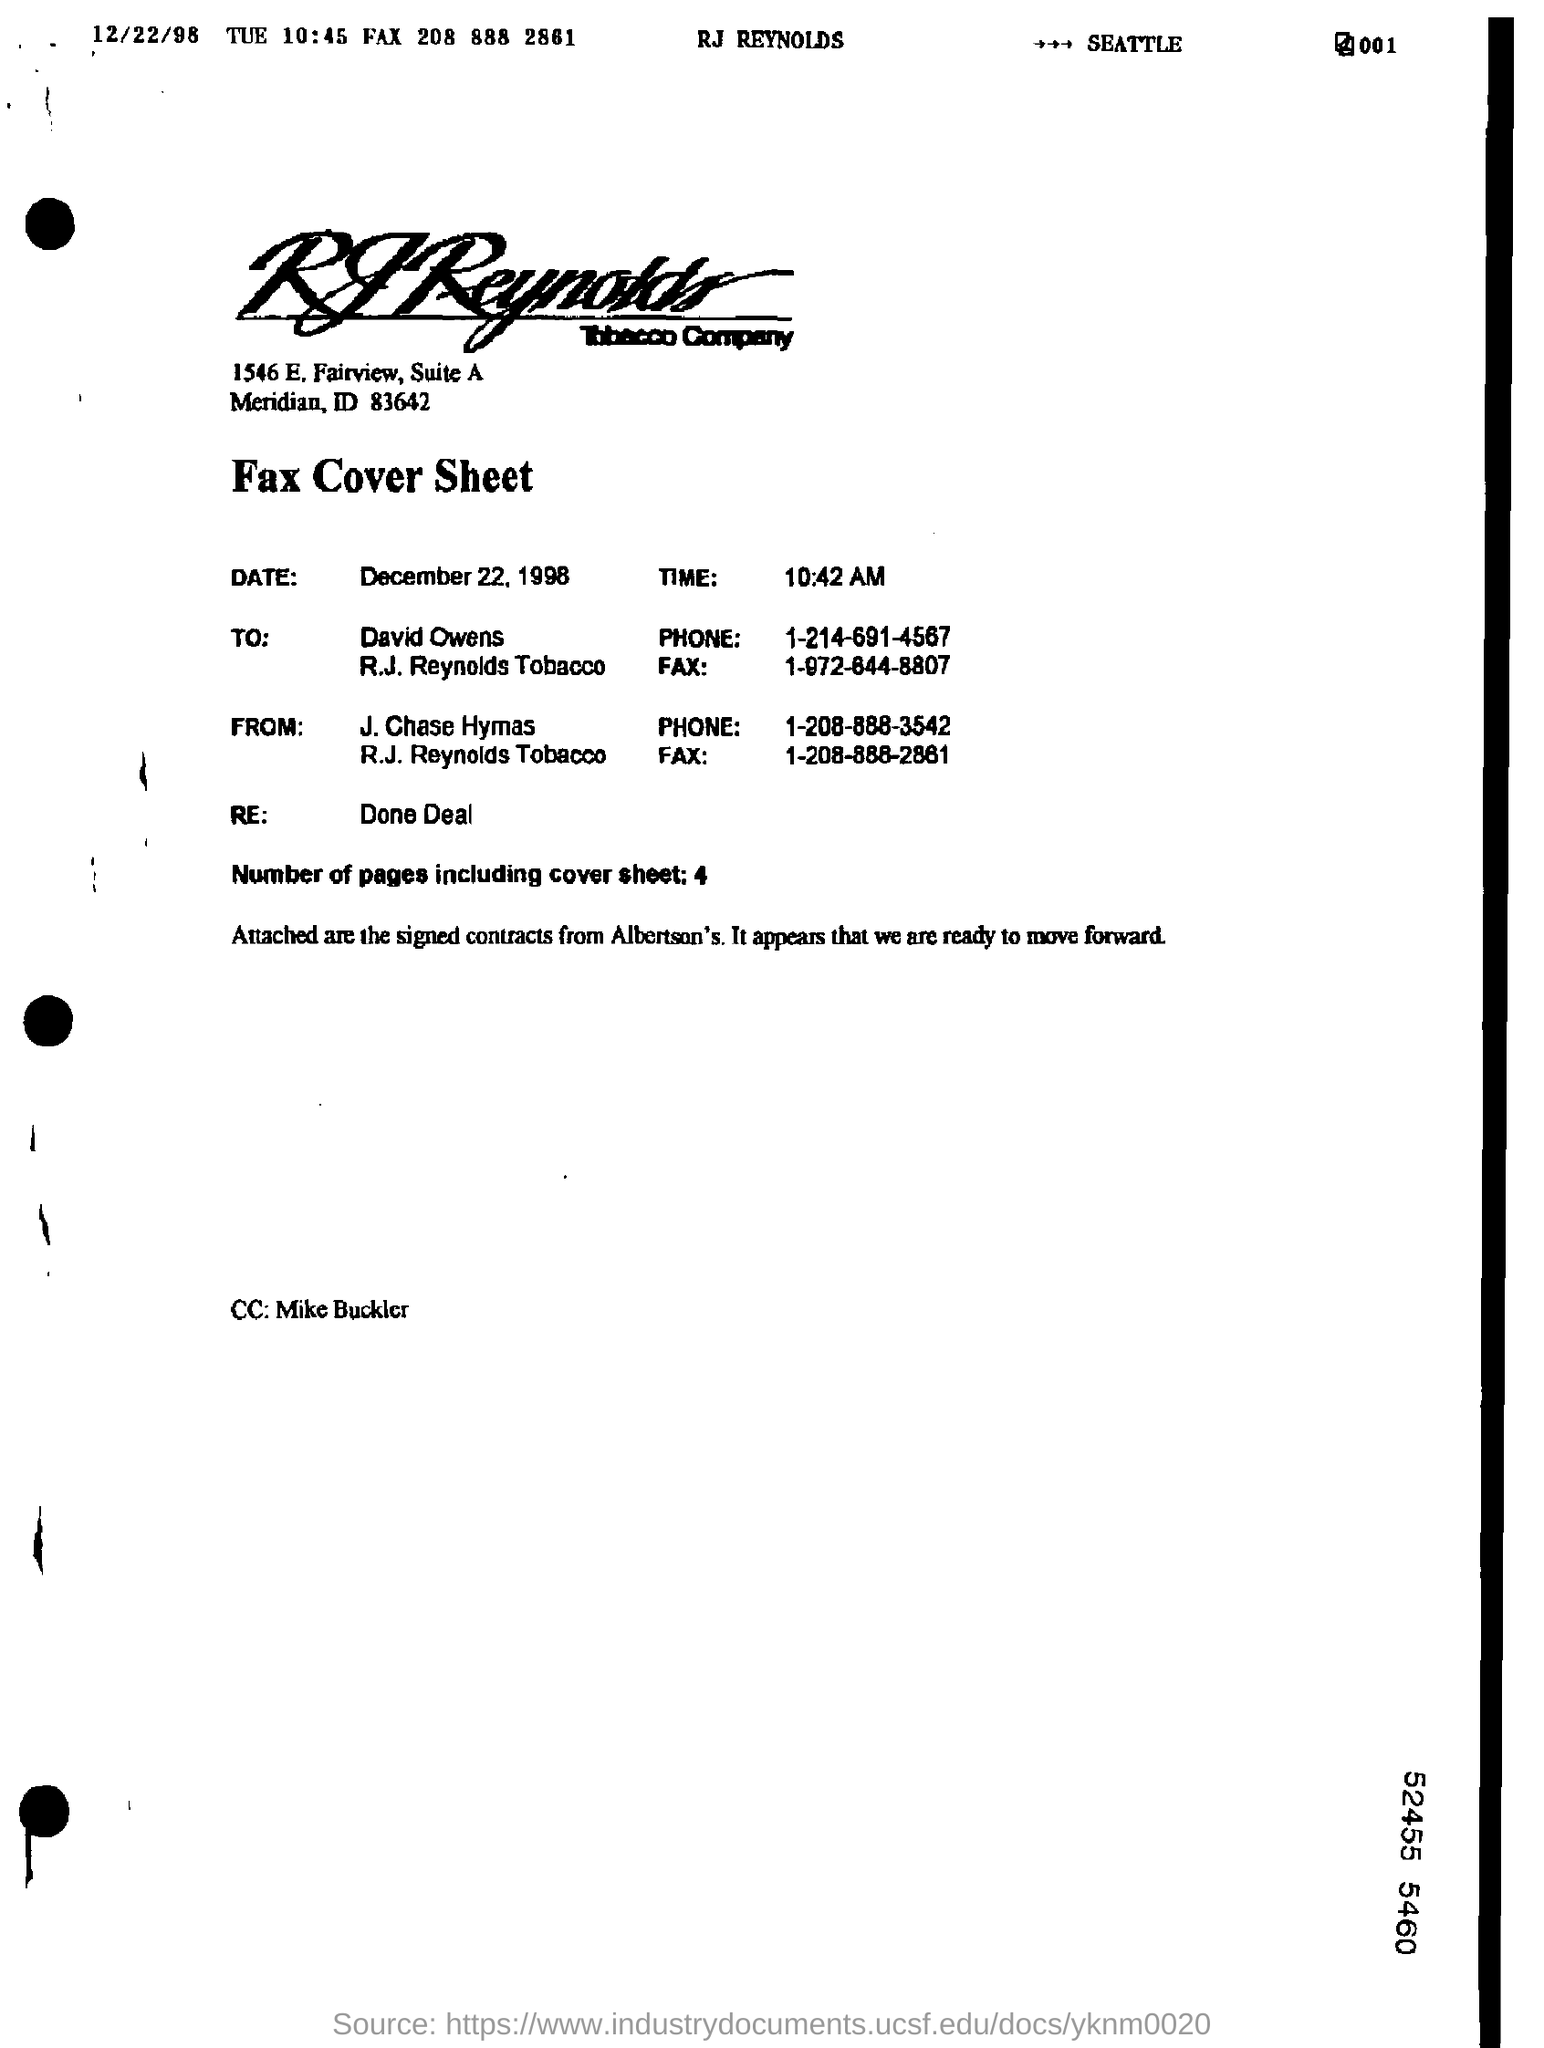Who is the sender of this FAX?
Provide a short and direct response. J. Chase Hymas. To whom, the Fax is being sent?
Provide a short and direct response. David Owens. How many pages are there in the fax including cover sheet?
Give a very brief answer. 4. Who is in the CC of the fax?
Keep it short and to the point. Mike Buckler. What is the time mentioned in fax cover sheet?
Offer a terse response. 10:42 AM. 